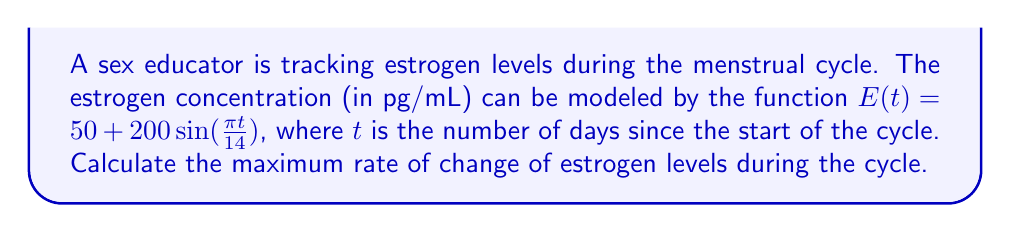Give your solution to this math problem. To find the maximum rate of change, we need to follow these steps:

1) The rate of change is given by the derivative of $E(t)$. Let's call this $E'(t)$.

2) Differentiate $E(t)$ with respect to $t$:
   $$E'(t) = 200 \cdot \frac{\pi}{14} \cos(\frac{\pi t}{14})$$

3) The maximum rate of change will occur when $\cos(\frac{\pi t}{14})$ is at its maximum or minimum, which is 1 or -1.

4) Therefore, the maximum absolute value of the rate of change is:
   $$|E'(t)_{max}| = 200 \cdot \frac{\pi}{14} \approx 44.88$$

5) This means the maximum rate of change is approximately 44.88 pg/mL per day, either increasing or decreasing.
Answer: $\frac{200\pi}{14}$ pg/mL/day 